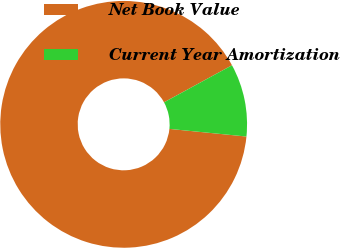Convert chart to OTSL. <chart><loc_0><loc_0><loc_500><loc_500><pie_chart><fcel>Net Book Value<fcel>Current Year Amortization<nl><fcel>90.48%<fcel>9.52%<nl></chart> 